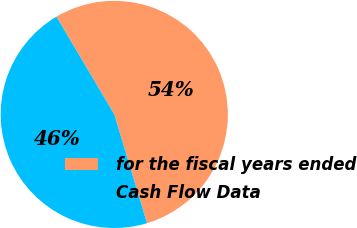Convert chart to OTSL. <chart><loc_0><loc_0><loc_500><loc_500><pie_chart><fcel>for the fiscal years ended<fcel>Cash Flow Data<nl><fcel>53.85%<fcel>46.15%<nl></chart> 